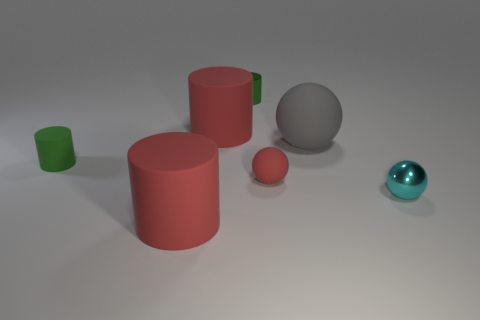Subtract all matte cylinders. How many cylinders are left? 1 Subtract 1 cylinders. How many cylinders are left? 3 Subtract all blue blocks. How many green cylinders are left? 2 Add 1 green metal cylinders. How many objects exist? 8 Subtract all cyan spheres. How many spheres are left? 2 Subtract all cyan cylinders. Subtract all red spheres. How many cylinders are left? 4 Subtract all cylinders. How many objects are left? 3 Add 6 large matte things. How many large matte things are left? 9 Add 4 small blue balls. How many small blue balls exist? 4 Subtract 0 blue cylinders. How many objects are left? 7 